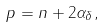<formula> <loc_0><loc_0><loc_500><loc_500>p = n + 2 \alpha _ { \delta } ,</formula> 